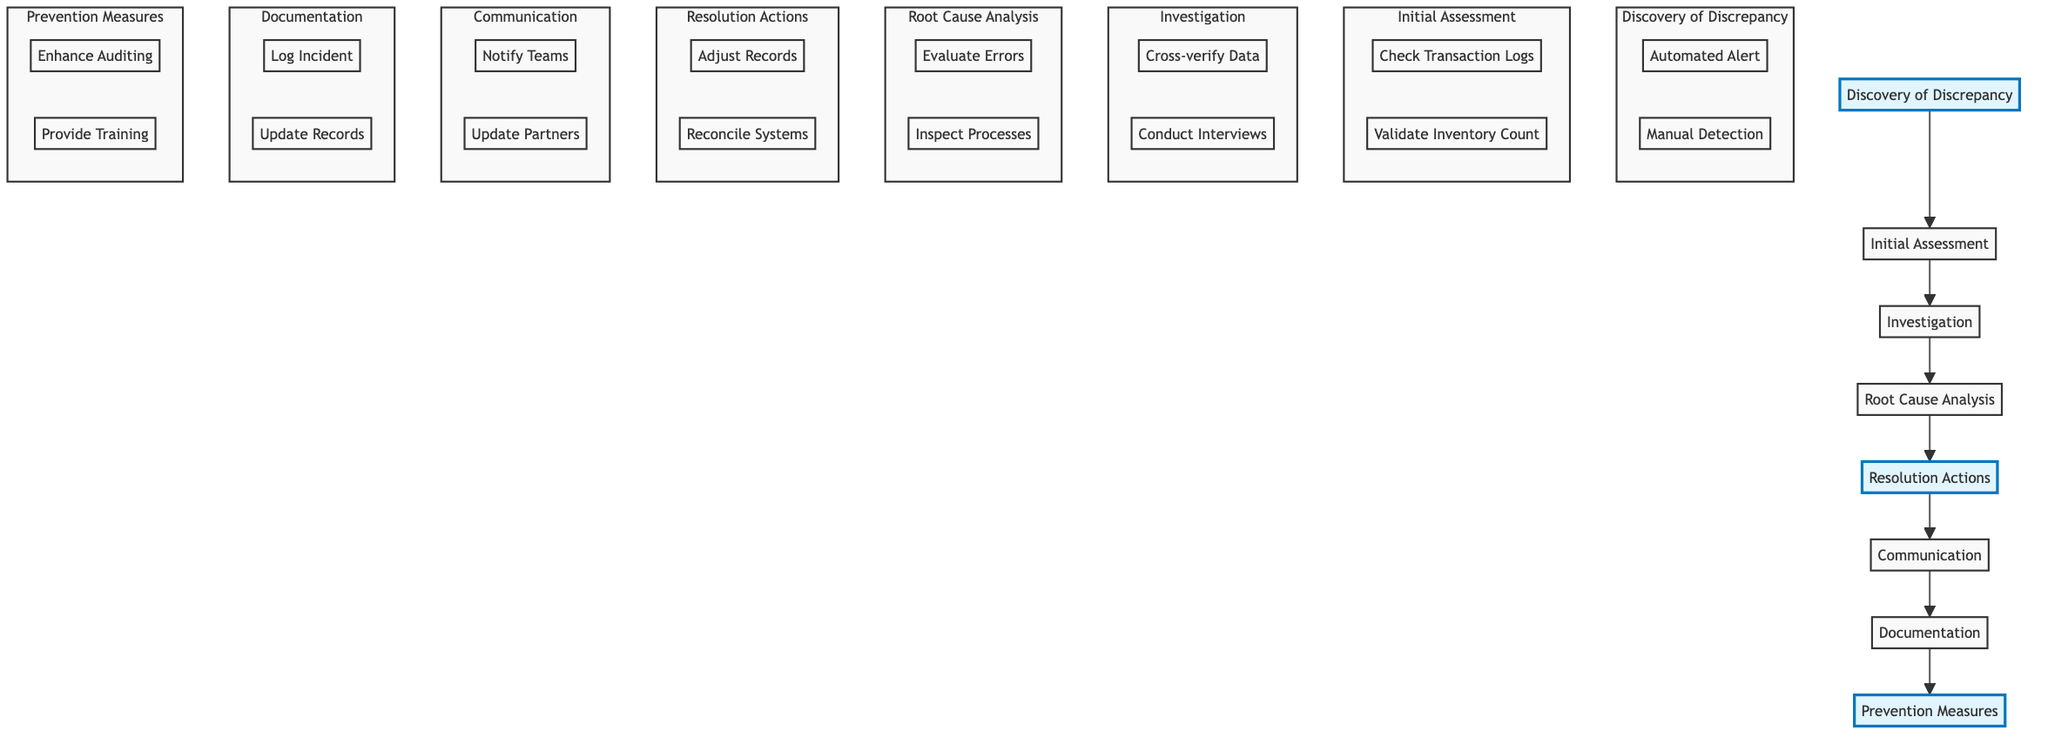What is the first step in the incident response process? The first step is represented by the node at the bottom of the flowchart, labeled "Discovery of Discrepancy". This is where the process initiates upon noticing an inventory discrepancy.
Answer: Discovery of Discrepancy How many main steps are there in the incident response process? The flowchart outlines eight main steps. Each step can be viewed as a node leading upwards from discovery to prevention.
Answer: Eight Which action is taken during the "Investigation" stage? In the "Investigation" stage, notable actions include "Cross-verify Inventory Data with Supplier Records" and "Conduct Interviews with Relevant Staff". Selecting any of these would be correct.
Answer: Cross-verify Inventory Data with Supplier Records What happens after “Root Cause Analysis”? Following the "Root Cause Analysis", the process moves to the next step labeled "Resolution Actions", demonstrating the flow of actions taken sequentially to address the discrepancy.
Answer: Resolution Actions Which step involves informing stakeholders? The step that involves informing stakeholders is "Communication", which specifically addresses notifying relevant teams after the resolution actions are taken.
Answer: Communication What actions are taken during the "Prevention Measures"? Actions detailed in the "Prevention Measures" step include "Enhance Inventory Auditing Processes" and "Provide Additional Training to Staff on Inventory Handling". Any of these actions would serve as an answer.
Answer: Enhance Inventory Auditing Processes Identify the last step of the incident response process. The last step in the incident response process, as shown at the top of the flowchart, is labeled "Prevention Measures". This step indicates ongoing efforts to avoid future discrepancies.
Answer: Prevention Measures What is the primary purpose of the "Documentation" step? The purpose of "Documentation" is to record essential details about the incident, the investigation process, and the actions taken to resolve it. This lays the groundwork for future reference and learning outcomes.
Answer: Record incident details Which action precedes the "Resolution Actions"? The action that comes immediately before "Resolution Actions" is "Root Cause Analysis", which helps identify the specific issues that need to be addressed before any corrections can be made.
Answer: Root Cause Analysis 